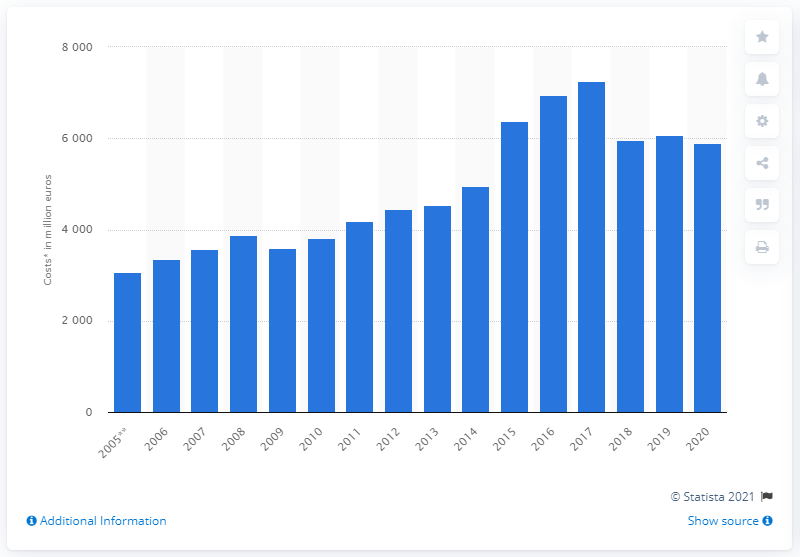Specify some key components in this picture. In 2020, Bosch's expenditures on research and development totaled approximately 5,890. Bosch experienced a 58.9% decrease in research and development spending in the fiscal year of 2020. 